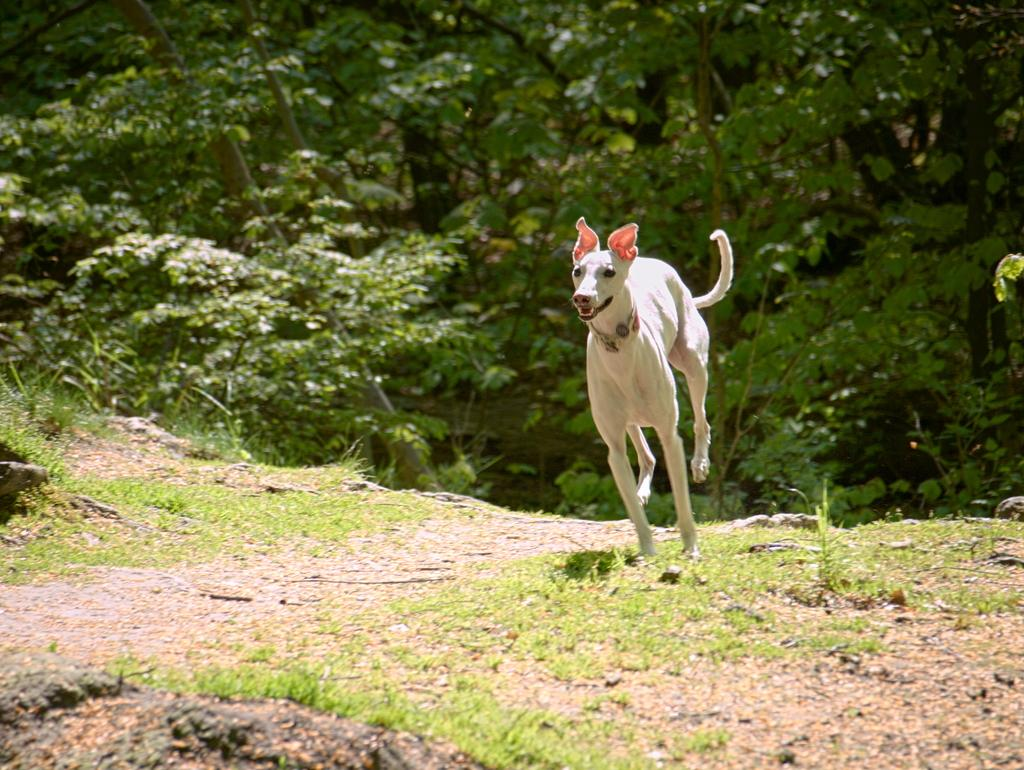What is the person in the image doing? The person is running in the image. What surface is the person running on? The person is running on the ground. What can be seen in the background of the image? There are trees in the background of the image. What type of reaction can be seen from the person's brain in the image? There is no indication of the person's brain or any reactions in the image. 